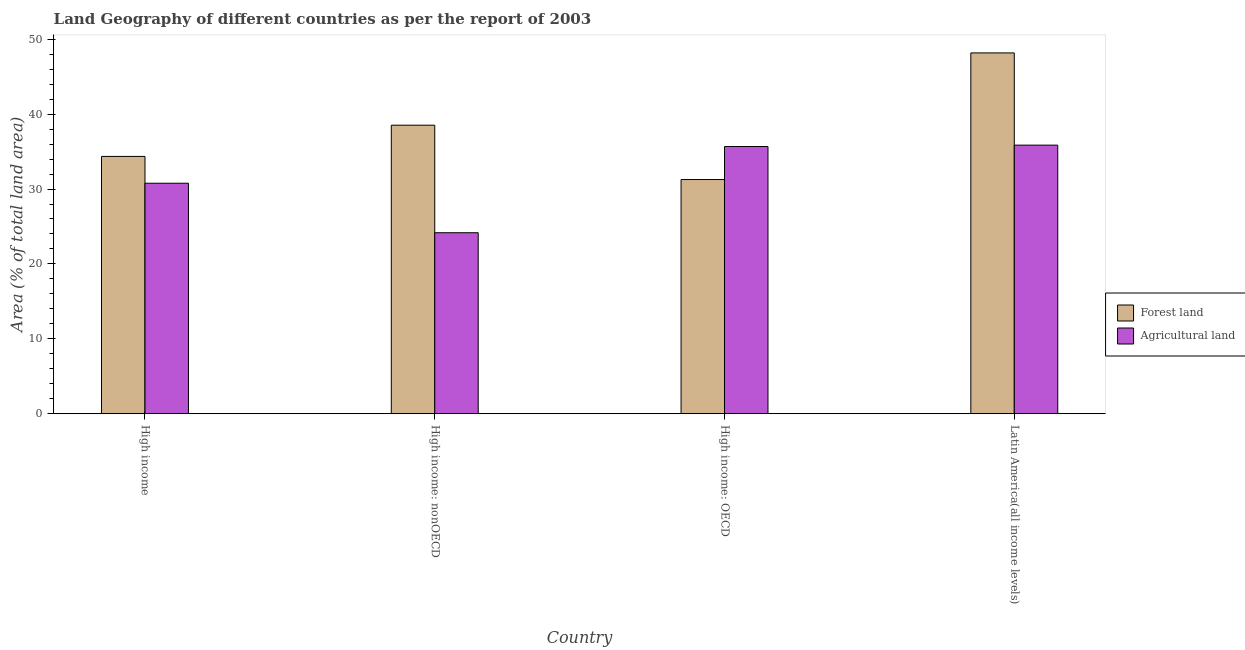How many different coloured bars are there?
Make the answer very short. 2. How many groups of bars are there?
Keep it short and to the point. 4. Are the number of bars on each tick of the X-axis equal?
Your answer should be very brief. Yes. How many bars are there on the 1st tick from the left?
Offer a terse response. 2. What is the label of the 2nd group of bars from the left?
Offer a very short reply. High income: nonOECD. In how many cases, is the number of bars for a given country not equal to the number of legend labels?
Your response must be concise. 0. What is the percentage of land area under agriculture in High income?
Give a very brief answer. 30.77. Across all countries, what is the maximum percentage of land area under forests?
Make the answer very short. 48.17. Across all countries, what is the minimum percentage of land area under forests?
Offer a very short reply. 31.27. In which country was the percentage of land area under forests maximum?
Your answer should be very brief. Latin America(all income levels). In which country was the percentage of land area under forests minimum?
Your response must be concise. High income: OECD. What is the total percentage of land area under forests in the graph?
Offer a very short reply. 152.32. What is the difference between the percentage of land area under forests in High income and that in Latin America(all income levels)?
Your response must be concise. -13.82. What is the difference between the percentage of land area under forests in Latin America(all income levels) and the percentage of land area under agriculture in High income?
Provide a succinct answer. 17.4. What is the average percentage of land area under forests per country?
Provide a short and direct response. 38.08. What is the difference between the percentage of land area under agriculture and percentage of land area under forests in High income: nonOECD?
Offer a terse response. -14.36. In how many countries, is the percentage of land area under agriculture greater than 44 %?
Your response must be concise. 0. What is the ratio of the percentage of land area under forests in High income: OECD to that in Latin America(all income levels)?
Make the answer very short. 0.65. What is the difference between the highest and the second highest percentage of land area under forests?
Offer a terse response. 9.65. What is the difference between the highest and the lowest percentage of land area under forests?
Give a very brief answer. 16.9. In how many countries, is the percentage of land area under agriculture greater than the average percentage of land area under agriculture taken over all countries?
Provide a short and direct response. 2. What does the 2nd bar from the left in High income: OECD represents?
Keep it short and to the point. Agricultural land. What does the 1st bar from the right in High income: nonOECD represents?
Your response must be concise. Agricultural land. How many countries are there in the graph?
Make the answer very short. 4. What is the difference between two consecutive major ticks on the Y-axis?
Give a very brief answer. 10. Where does the legend appear in the graph?
Ensure brevity in your answer.  Center right. How many legend labels are there?
Keep it short and to the point. 2. What is the title of the graph?
Your answer should be very brief. Land Geography of different countries as per the report of 2003. Does "Domestic Liabilities" appear as one of the legend labels in the graph?
Offer a terse response. No. What is the label or title of the Y-axis?
Your answer should be compact. Area (% of total land area). What is the Area (% of total land area) in Forest land in High income?
Make the answer very short. 34.35. What is the Area (% of total land area) of Agricultural land in High income?
Your response must be concise. 30.77. What is the Area (% of total land area) of Forest land in High income: nonOECD?
Provide a succinct answer. 38.52. What is the Area (% of total land area) in Agricultural land in High income: nonOECD?
Keep it short and to the point. 24.17. What is the Area (% of total land area) of Forest land in High income: OECD?
Your answer should be compact. 31.27. What is the Area (% of total land area) in Agricultural land in High income: OECD?
Make the answer very short. 35.68. What is the Area (% of total land area) in Forest land in Latin America(all income levels)?
Ensure brevity in your answer.  48.17. What is the Area (% of total land area) in Agricultural land in Latin America(all income levels)?
Make the answer very short. 35.86. Across all countries, what is the maximum Area (% of total land area) of Forest land?
Keep it short and to the point. 48.17. Across all countries, what is the maximum Area (% of total land area) in Agricultural land?
Your answer should be very brief. 35.86. Across all countries, what is the minimum Area (% of total land area) in Forest land?
Give a very brief answer. 31.27. Across all countries, what is the minimum Area (% of total land area) in Agricultural land?
Ensure brevity in your answer.  24.17. What is the total Area (% of total land area) in Forest land in the graph?
Your response must be concise. 152.32. What is the total Area (% of total land area) in Agricultural land in the graph?
Your answer should be compact. 126.48. What is the difference between the Area (% of total land area) in Forest land in High income and that in High income: nonOECD?
Provide a short and direct response. -4.17. What is the difference between the Area (% of total land area) in Agricultural land in High income and that in High income: nonOECD?
Your answer should be very brief. 6.61. What is the difference between the Area (% of total land area) of Forest land in High income and that in High income: OECD?
Your answer should be very brief. 3.09. What is the difference between the Area (% of total land area) in Agricultural land in High income and that in High income: OECD?
Your answer should be very brief. -4.9. What is the difference between the Area (% of total land area) in Forest land in High income and that in Latin America(all income levels)?
Offer a very short reply. -13.82. What is the difference between the Area (% of total land area) of Agricultural land in High income and that in Latin America(all income levels)?
Your answer should be very brief. -5.09. What is the difference between the Area (% of total land area) of Forest land in High income: nonOECD and that in High income: OECD?
Offer a terse response. 7.25. What is the difference between the Area (% of total land area) of Agricultural land in High income: nonOECD and that in High income: OECD?
Provide a short and direct response. -11.51. What is the difference between the Area (% of total land area) in Forest land in High income: nonOECD and that in Latin America(all income levels)?
Give a very brief answer. -9.65. What is the difference between the Area (% of total land area) in Agricultural land in High income: nonOECD and that in Latin America(all income levels)?
Your answer should be compact. -11.7. What is the difference between the Area (% of total land area) of Forest land in High income: OECD and that in Latin America(all income levels)?
Keep it short and to the point. -16.9. What is the difference between the Area (% of total land area) of Agricultural land in High income: OECD and that in Latin America(all income levels)?
Provide a short and direct response. -0.18. What is the difference between the Area (% of total land area) of Forest land in High income and the Area (% of total land area) of Agricultural land in High income: nonOECD?
Offer a very short reply. 10.19. What is the difference between the Area (% of total land area) of Forest land in High income and the Area (% of total land area) of Agricultural land in High income: OECD?
Your answer should be very brief. -1.32. What is the difference between the Area (% of total land area) in Forest land in High income and the Area (% of total land area) in Agricultural land in Latin America(all income levels)?
Provide a short and direct response. -1.51. What is the difference between the Area (% of total land area) of Forest land in High income: nonOECD and the Area (% of total land area) of Agricultural land in High income: OECD?
Offer a very short reply. 2.85. What is the difference between the Area (% of total land area) in Forest land in High income: nonOECD and the Area (% of total land area) in Agricultural land in Latin America(all income levels)?
Ensure brevity in your answer.  2.66. What is the difference between the Area (% of total land area) in Forest land in High income: OECD and the Area (% of total land area) in Agricultural land in Latin America(all income levels)?
Your answer should be compact. -4.59. What is the average Area (% of total land area) of Forest land per country?
Provide a succinct answer. 38.08. What is the average Area (% of total land area) in Agricultural land per country?
Offer a very short reply. 31.62. What is the difference between the Area (% of total land area) of Forest land and Area (% of total land area) of Agricultural land in High income?
Ensure brevity in your answer.  3.58. What is the difference between the Area (% of total land area) of Forest land and Area (% of total land area) of Agricultural land in High income: nonOECD?
Keep it short and to the point. 14.36. What is the difference between the Area (% of total land area) in Forest land and Area (% of total land area) in Agricultural land in High income: OECD?
Provide a short and direct response. -4.41. What is the difference between the Area (% of total land area) in Forest land and Area (% of total land area) in Agricultural land in Latin America(all income levels)?
Make the answer very short. 12.31. What is the ratio of the Area (% of total land area) of Forest land in High income to that in High income: nonOECD?
Your answer should be very brief. 0.89. What is the ratio of the Area (% of total land area) of Agricultural land in High income to that in High income: nonOECD?
Provide a succinct answer. 1.27. What is the ratio of the Area (% of total land area) in Forest land in High income to that in High income: OECD?
Your response must be concise. 1.1. What is the ratio of the Area (% of total land area) in Agricultural land in High income to that in High income: OECD?
Your response must be concise. 0.86. What is the ratio of the Area (% of total land area) in Forest land in High income to that in Latin America(all income levels)?
Ensure brevity in your answer.  0.71. What is the ratio of the Area (% of total land area) of Agricultural land in High income to that in Latin America(all income levels)?
Give a very brief answer. 0.86. What is the ratio of the Area (% of total land area) in Forest land in High income: nonOECD to that in High income: OECD?
Make the answer very short. 1.23. What is the ratio of the Area (% of total land area) in Agricultural land in High income: nonOECD to that in High income: OECD?
Make the answer very short. 0.68. What is the ratio of the Area (% of total land area) in Forest land in High income: nonOECD to that in Latin America(all income levels)?
Provide a short and direct response. 0.8. What is the ratio of the Area (% of total land area) in Agricultural land in High income: nonOECD to that in Latin America(all income levels)?
Provide a short and direct response. 0.67. What is the ratio of the Area (% of total land area) of Forest land in High income: OECD to that in Latin America(all income levels)?
Provide a short and direct response. 0.65. What is the ratio of the Area (% of total land area) of Agricultural land in High income: OECD to that in Latin America(all income levels)?
Provide a succinct answer. 0.99. What is the difference between the highest and the second highest Area (% of total land area) in Forest land?
Give a very brief answer. 9.65. What is the difference between the highest and the second highest Area (% of total land area) of Agricultural land?
Make the answer very short. 0.18. What is the difference between the highest and the lowest Area (% of total land area) in Forest land?
Make the answer very short. 16.9. What is the difference between the highest and the lowest Area (% of total land area) in Agricultural land?
Offer a terse response. 11.7. 